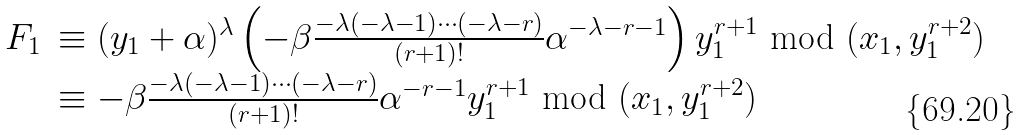Convert formula to latex. <formula><loc_0><loc_0><loc_500><loc_500>\begin{array} { l l } F _ { 1 } & \equiv ( y _ { 1 } + \alpha ) ^ { \lambda } \left ( - \beta \frac { - \lambda ( - \lambda - 1 ) \cdots ( - \lambda - r ) } { ( r + 1 ) ! } \alpha ^ { - \lambda - r - 1 } \right ) y _ { 1 } ^ { r + 1 } \text { mod } ( x _ { 1 } , y _ { 1 } ^ { r + 2 } ) \\ & \equiv - \beta \frac { - \lambda ( - \lambda - 1 ) \cdots ( - \lambda - r ) } { ( r + 1 ) ! } \alpha ^ { - r - 1 } y _ { 1 } ^ { r + 1 } \text { mod } ( x _ { 1 } , y _ { 1 } ^ { r + 2 } ) \end{array}</formula> 